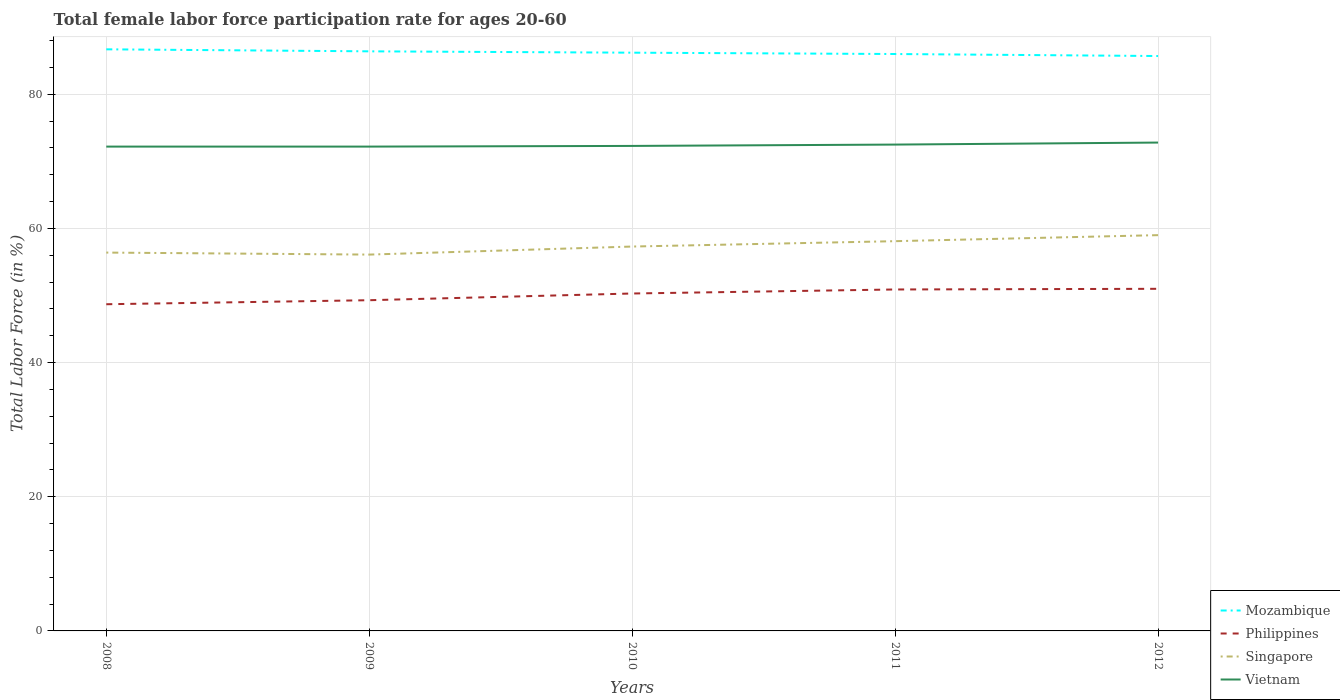How many different coloured lines are there?
Ensure brevity in your answer.  4. Across all years, what is the maximum female labor force participation rate in Philippines?
Ensure brevity in your answer.  48.7. What is the total female labor force participation rate in Vietnam in the graph?
Offer a terse response. -0.1. What is the difference between the highest and the second highest female labor force participation rate in Vietnam?
Make the answer very short. 0.6. What is the difference between the highest and the lowest female labor force participation rate in Philippines?
Your answer should be very brief. 3. Is the female labor force participation rate in Philippines strictly greater than the female labor force participation rate in Singapore over the years?
Make the answer very short. Yes. How many lines are there?
Your response must be concise. 4. Are the values on the major ticks of Y-axis written in scientific E-notation?
Make the answer very short. No. Does the graph contain any zero values?
Offer a very short reply. No. Does the graph contain grids?
Your response must be concise. Yes. How are the legend labels stacked?
Keep it short and to the point. Vertical. What is the title of the graph?
Keep it short and to the point. Total female labor force participation rate for ages 20-60. Does "New Caledonia" appear as one of the legend labels in the graph?
Offer a very short reply. No. What is the label or title of the Y-axis?
Give a very brief answer. Total Labor Force (in %). What is the Total Labor Force (in %) of Mozambique in 2008?
Ensure brevity in your answer.  86.7. What is the Total Labor Force (in %) in Philippines in 2008?
Offer a terse response. 48.7. What is the Total Labor Force (in %) of Singapore in 2008?
Provide a short and direct response. 56.4. What is the Total Labor Force (in %) in Vietnam in 2008?
Offer a very short reply. 72.2. What is the Total Labor Force (in %) in Mozambique in 2009?
Your response must be concise. 86.4. What is the Total Labor Force (in %) in Philippines in 2009?
Provide a short and direct response. 49.3. What is the Total Labor Force (in %) in Singapore in 2009?
Provide a succinct answer. 56.1. What is the Total Labor Force (in %) of Vietnam in 2009?
Make the answer very short. 72.2. What is the Total Labor Force (in %) of Mozambique in 2010?
Provide a succinct answer. 86.2. What is the Total Labor Force (in %) of Philippines in 2010?
Ensure brevity in your answer.  50.3. What is the Total Labor Force (in %) of Singapore in 2010?
Your answer should be compact. 57.3. What is the Total Labor Force (in %) of Vietnam in 2010?
Provide a succinct answer. 72.3. What is the Total Labor Force (in %) of Philippines in 2011?
Offer a very short reply. 50.9. What is the Total Labor Force (in %) in Singapore in 2011?
Ensure brevity in your answer.  58.1. What is the Total Labor Force (in %) in Vietnam in 2011?
Ensure brevity in your answer.  72.5. What is the Total Labor Force (in %) in Mozambique in 2012?
Ensure brevity in your answer.  85.7. What is the Total Labor Force (in %) of Vietnam in 2012?
Your answer should be very brief. 72.8. Across all years, what is the maximum Total Labor Force (in %) in Mozambique?
Keep it short and to the point. 86.7. Across all years, what is the maximum Total Labor Force (in %) in Philippines?
Your answer should be compact. 51. Across all years, what is the maximum Total Labor Force (in %) in Singapore?
Offer a very short reply. 59. Across all years, what is the maximum Total Labor Force (in %) in Vietnam?
Offer a terse response. 72.8. Across all years, what is the minimum Total Labor Force (in %) in Mozambique?
Ensure brevity in your answer.  85.7. Across all years, what is the minimum Total Labor Force (in %) of Philippines?
Provide a succinct answer. 48.7. Across all years, what is the minimum Total Labor Force (in %) of Singapore?
Offer a terse response. 56.1. Across all years, what is the minimum Total Labor Force (in %) of Vietnam?
Offer a very short reply. 72.2. What is the total Total Labor Force (in %) in Mozambique in the graph?
Your answer should be very brief. 431. What is the total Total Labor Force (in %) of Philippines in the graph?
Make the answer very short. 250.2. What is the total Total Labor Force (in %) in Singapore in the graph?
Ensure brevity in your answer.  286.9. What is the total Total Labor Force (in %) of Vietnam in the graph?
Provide a succinct answer. 362. What is the difference between the Total Labor Force (in %) in Singapore in 2008 and that in 2009?
Provide a succinct answer. 0.3. What is the difference between the Total Labor Force (in %) of Philippines in 2008 and that in 2010?
Ensure brevity in your answer.  -1.6. What is the difference between the Total Labor Force (in %) of Singapore in 2008 and that in 2010?
Give a very brief answer. -0.9. What is the difference between the Total Labor Force (in %) in Vietnam in 2008 and that in 2011?
Your answer should be very brief. -0.3. What is the difference between the Total Labor Force (in %) in Philippines in 2008 and that in 2012?
Offer a very short reply. -2.3. What is the difference between the Total Labor Force (in %) of Singapore in 2008 and that in 2012?
Provide a short and direct response. -2.6. What is the difference between the Total Labor Force (in %) in Singapore in 2009 and that in 2010?
Give a very brief answer. -1.2. What is the difference between the Total Labor Force (in %) in Singapore in 2009 and that in 2011?
Ensure brevity in your answer.  -2. What is the difference between the Total Labor Force (in %) of Mozambique in 2009 and that in 2012?
Your answer should be very brief. 0.7. What is the difference between the Total Labor Force (in %) in Singapore in 2009 and that in 2012?
Provide a short and direct response. -2.9. What is the difference between the Total Labor Force (in %) of Vietnam in 2009 and that in 2012?
Your answer should be very brief. -0.6. What is the difference between the Total Labor Force (in %) in Philippines in 2010 and that in 2011?
Offer a very short reply. -0.6. What is the difference between the Total Labor Force (in %) of Mozambique in 2010 and that in 2012?
Your response must be concise. 0.5. What is the difference between the Total Labor Force (in %) in Vietnam in 2010 and that in 2012?
Make the answer very short. -0.5. What is the difference between the Total Labor Force (in %) of Mozambique in 2011 and that in 2012?
Ensure brevity in your answer.  0.3. What is the difference between the Total Labor Force (in %) of Vietnam in 2011 and that in 2012?
Offer a terse response. -0.3. What is the difference between the Total Labor Force (in %) in Mozambique in 2008 and the Total Labor Force (in %) in Philippines in 2009?
Give a very brief answer. 37.4. What is the difference between the Total Labor Force (in %) of Mozambique in 2008 and the Total Labor Force (in %) of Singapore in 2009?
Keep it short and to the point. 30.6. What is the difference between the Total Labor Force (in %) in Philippines in 2008 and the Total Labor Force (in %) in Vietnam in 2009?
Offer a very short reply. -23.5. What is the difference between the Total Labor Force (in %) in Singapore in 2008 and the Total Labor Force (in %) in Vietnam in 2009?
Offer a terse response. -15.8. What is the difference between the Total Labor Force (in %) in Mozambique in 2008 and the Total Labor Force (in %) in Philippines in 2010?
Provide a succinct answer. 36.4. What is the difference between the Total Labor Force (in %) of Mozambique in 2008 and the Total Labor Force (in %) of Singapore in 2010?
Your answer should be very brief. 29.4. What is the difference between the Total Labor Force (in %) in Mozambique in 2008 and the Total Labor Force (in %) in Vietnam in 2010?
Offer a very short reply. 14.4. What is the difference between the Total Labor Force (in %) of Philippines in 2008 and the Total Labor Force (in %) of Vietnam in 2010?
Your answer should be compact. -23.6. What is the difference between the Total Labor Force (in %) in Singapore in 2008 and the Total Labor Force (in %) in Vietnam in 2010?
Offer a terse response. -15.9. What is the difference between the Total Labor Force (in %) of Mozambique in 2008 and the Total Labor Force (in %) of Philippines in 2011?
Provide a succinct answer. 35.8. What is the difference between the Total Labor Force (in %) in Mozambique in 2008 and the Total Labor Force (in %) in Singapore in 2011?
Your answer should be very brief. 28.6. What is the difference between the Total Labor Force (in %) in Philippines in 2008 and the Total Labor Force (in %) in Singapore in 2011?
Your answer should be very brief. -9.4. What is the difference between the Total Labor Force (in %) in Philippines in 2008 and the Total Labor Force (in %) in Vietnam in 2011?
Your answer should be very brief. -23.8. What is the difference between the Total Labor Force (in %) of Singapore in 2008 and the Total Labor Force (in %) of Vietnam in 2011?
Offer a terse response. -16.1. What is the difference between the Total Labor Force (in %) in Mozambique in 2008 and the Total Labor Force (in %) in Philippines in 2012?
Your answer should be compact. 35.7. What is the difference between the Total Labor Force (in %) of Mozambique in 2008 and the Total Labor Force (in %) of Singapore in 2012?
Give a very brief answer. 27.7. What is the difference between the Total Labor Force (in %) of Mozambique in 2008 and the Total Labor Force (in %) of Vietnam in 2012?
Your response must be concise. 13.9. What is the difference between the Total Labor Force (in %) in Philippines in 2008 and the Total Labor Force (in %) in Vietnam in 2012?
Provide a succinct answer. -24.1. What is the difference between the Total Labor Force (in %) in Singapore in 2008 and the Total Labor Force (in %) in Vietnam in 2012?
Provide a succinct answer. -16.4. What is the difference between the Total Labor Force (in %) in Mozambique in 2009 and the Total Labor Force (in %) in Philippines in 2010?
Provide a succinct answer. 36.1. What is the difference between the Total Labor Force (in %) of Mozambique in 2009 and the Total Labor Force (in %) of Singapore in 2010?
Provide a short and direct response. 29.1. What is the difference between the Total Labor Force (in %) of Philippines in 2009 and the Total Labor Force (in %) of Vietnam in 2010?
Your response must be concise. -23. What is the difference between the Total Labor Force (in %) of Singapore in 2009 and the Total Labor Force (in %) of Vietnam in 2010?
Give a very brief answer. -16.2. What is the difference between the Total Labor Force (in %) of Mozambique in 2009 and the Total Labor Force (in %) of Philippines in 2011?
Your answer should be compact. 35.5. What is the difference between the Total Labor Force (in %) of Mozambique in 2009 and the Total Labor Force (in %) of Singapore in 2011?
Keep it short and to the point. 28.3. What is the difference between the Total Labor Force (in %) in Philippines in 2009 and the Total Labor Force (in %) in Singapore in 2011?
Keep it short and to the point. -8.8. What is the difference between the Total Labor Force (in %) of Philippines in 2009 and the Total Labor Force (in %) of Vietnam in 2011?
Your response must be concise. -23.2. What is the difference between the Total Labor Force (in %) in Singapore in 2009 and the Total Labor Force (in %) in Vietnam in 2011?
Make the answer very short. -16.4. What is the difference between the Total Labor Force (in %) in Mozambique in 2009 and the Total Labor Force (in %) in Philippines in 2012?
Ensure brevity in your answer.  35.4. What is the difference between the Total Labor Force (in %) of Mozambique in 2009 and the Total Labor Force (in %) of Singapore in 2012?
Your response must be concise. 27.4. What is the difference between the Total Labor Force (in %) in Mozambique in 2009 and the Total Labor Force (in %) in Vietnam in 2012?
Ensure brevity in your answer.  13.6. What is the difference between the Total Labor Force (in %) of Philippines in 2009 and the Total Labor Force (in %) of Singapore in 2012?
Ensure brevity in your answer.  -9.7. What is the difference between the Total Labor Force (in %) of Philippines in 2009 and the Total Labor Force (in %) of Vietnam in 2012?
Offer a very short reply. -23.5. What is the difference between the Total Labor Force (in %) of Singapore in 2009 and the Total Labor Force (in %) of Vietnam in 2012?
Make the answer very short. -16.7. What is the difference between the Total Labor Force (in %) of Mozambique in 2010 and the Total Labor Force (in %) of Philippines in 2011?
Keep it short and to the point. 35.3. What is the difference between the Total Labor Force (in %) in Mozambique in 2010 and the Total Labor Force (in %) in Singapore in 2011?
Your answer should be compact. 28.1. What is the difference between the Total Labor Force (in %) of Philippines in 2010 and the Total Labor Force (in %) of Singapore in 2011?
Your response must be concise. -7.8. What is the difference between the Total Labor Force (in %) of Philippines in 2010 and the Total Labor Force (in %) of Vietnam in 2011?
Provide a short and direct response. -22.2. What is the difference between the Total Labor Force (in %) of Singapore in 2010 and the Total Labor Force (in %) of Vietnam in 2011?
Keep it short and to the point. -15.2. What is the difference between the Total Labor Force (in %) of Mozambique in 2010 and the Total Labor Force (in %) of Philippines in 2012?
Your answer should be very brief. 35.2. What is the difference between the Total Labor Force (in %) of Mozambique in 2010 and the Total Labor Force (in %) of Singapore in 2012?
Give a very brief answer. 27.2. What is the difference between the Total Labor Force (in %) of Philippines in 2010 and the Total Labor Force (in %) of Singapore in 2012?
Your answer should be compact. -8.7. What is the difference between the Total Labor Force (in %) in Philippines in 2010 and the Total Labor Force (in %) in Vietnam in 2012?
Offer a very short reply. -22.5. What is the difference between the Total Labor Force (in %) in Singapore in 2010 and the Total Labor Force (in %) in Vietnam in 2012?
Offer a very short reply. -15.5. What is the difference between the Total Labor Force (in %) in Mozambique in 2011 and the Total Labor Force (in %) in Philippines in 2012?
Give a very brief answer. 35. What is the difference between the Total Labor Force (in %) of Mozambique in 2011 and the Total Labor Force (in %) of Singapore in 2012?
Your answer should be compact. 27. What is the difference between the Total Labor Force (in %) in Mozambique in 2011 and the Total Labor Force (in %) in Vietnam in 2012?
Provide a succinct answer. 13.2. What is the difference between the Total Labor Force (in %) in Philippines in 2011 and the Total Labor Force (in %) in Vietnam in 2012?
Ensure brevity in your answer.  -21.9. What is the difference between the Total Labor Force (in %) of Singapore in 2011 and the Total Labor Force (in %) of Vietnam in 2012?
Ensure brevity in your answer.  -14.7. What is the average Total Labor Force (in %) in Mozambique per year?
Offer a terse response. 86.2. What is the average Total Labor Force (in %) in Philippines per year?
Make the answer very short. 50.04. What is the average Total Labor Force (in %) of Singapore per year?
Your answer should be compact. 57.38. What is the average Total Labor Force (in %) in Vietnam per year?
Keep it short and to the point. 72.4. In the year 2008, what is the difference between the Total Labor Force (in %) of Mozambique and Total Labor Force (in %) of Philippines?
Offer a terse response. 38. In the year 2008, what is the difference between the Total Labor Force (in %) in Mozambique and Total Labor Force (in %) in Singapore?
Offer a very short reply. 30.3. In the year 2008, what is the difference between the Total Labor Force (in %) of Philippines and Total Labor Force (in %) of Vietnam?
Your response must be concise. -23.5. In the year 2008, what is the difference between the Total Labor Force (in %) of Singapore and Total Labor Force (in %) of Vietnam?
Make the answer very short. -15.8. In the year 2009, what is the difference between the Total Labor Force (in %) in Mozambique and Total Labor Force (in %) in Philippines?
Make the answer very short. 37.1. In the year 2009, what is the difference between the Total Labor Force (in %) in Mozambique and Total Labor Force (in %) in Singapore?
Your answer should be compact. 30.3. In the year 2009, what is the difference between the Total Labor Force (in %) in Philippines and Total Labor Force (in %) in Singapore?
Your response must be concise. -6.8. In the year 2009, what is the difference between the Total Labor Force (in %) of Philippines and Total Labor Force (in %) of Vietnam?
Your response must be concise. -22.9. In the year 2009, what is the difference between the Total Labor Force (in %) in Singapore and Total Labor Force (in %) in Vietnam?
Provide a short and direct response. -16.1. In the year 2010, what is the difference between the Total Labor Force (in %) of Mozambique and Total Labor Force (in %) of Philippines?
Provide a succinct answer. 35.9. In the year 2010, what is the difference between the Total Labor Force (in %) in Mozambique and Total Labor Force (in %) in Singapore?
Give a very brief answer. 28.9. In the year 2010, what is the difference between the Total Labor Force (in %) in Philippines and Total Labor Force (in %) in Singapore?
Your response must be concise. -7. In the year 2010, what is the difference between the Total Labor Force (in %) in Philippines and Total Labor Force (in %) in Vietnam?
Keep it short and to the point. -22. In the year 2011, what is the difference between the Total Labor Force (in %) in Mozambique and Total Labor Force (in %) in Philippines?
Give a very brief answer. 35.1. In the year 2011, what is the difference between the Total Labor Force (in %) in Mozambique and Total Labor Force (in %) in Singapore?
Your answer should be very brief. 27.9. In the year 2011, what is the difference between the Total Labor Force (in %) of Philippines and Total Labor Force (in %) of Vietnam?
Your answer should be very brief. -21.6. In the year 2011, what is the difference between the Total Labor Force (in %) of Singapore and Total Labor Force (in %) of Vietnam?
Ensure brevity in your answer.  -14.4. In the year 2012, what is the difference between the Total Labor Force (in %) of Mozambique and Total Labor Force (in %) of Philippines?
Keep it short and to the point. 34.7. In the year 2012, what is the difference between the Total Labor Force (in %) in Mozambique and Total Labor Force (in %) in Singapore?
Offer a very short reply. 26.7. In the year 2012, what is the difference between the Total Labor Force (in %) in Philippines and Total Labor Force (in %) in Singapore?
Your answer should be very brief. -8. In the year 2012, what is the difference between the Total Labor Force (in %) of Philippines and Total Labor Force (in %) of Vietnam?
Provide a short and direct response. -21.8. What is the ratio of the Total Labor Force (in %) of Mozambique in 2008 to that in 2009?
Ensure brevity in your answer.  1. What is the ratio of the Total Labor Force (in %) in Singapore in 2008 to that in 2009?
Your answer should be very brief. 1.01. What is the ratio of the Total Labor Force (in %) in Vietnam in 2008 to that in 2009?
Your response must be concise. 1. What is the ratio of the Total Labor Force (in %) of Mozambique in 2008 to that in 2010?
Make the answer very short. 1.01. What is the ratio of the Total Labor Force (in %) in Philippines in 2008 to that in 2010?
Provide a short and direct response. 0.97. What is the ratio of the Total Labor Force (in %) of Singapore in 2008 to that in 2010?
Provide a short and direct response. 0.98. What is the ratio of the Total Labor Force (in %) in Vietnam in 2008 to that in 2010?
Offer a terse response. 1. What is the ratio of the Total Labor Force (in %) of Mozambique in 2008 to that in 2011?
Offer a very short reply. 1.01. What is the ratio of the Total Labor Force (in %) of Philippines in 2008 to that in 2011?
Offer a very short reply. 0.96. What is the ratio of the Total Labor Force (in %) of Singapore in 2008 to that in 2011?
Provide a succinct answer. 0.97. What is the ratio of the Total Labor Force (in %) of Mozambique in 2008 to that in 2012?
Your response must be concise. 1.01. What is the ratio of the Total Labor Force (in %) of Philippines in 2008 to that in 2012?
Give a very brief answer. 0.95. What is the ratio of the Total Labor Force (in %) in Singapore in 2008 to that in 2012?
Provide a short and direct response. 0.96. What is the ratio of the Total Labor Force (in %) of Mozambique in 2009 to that in 2010?
Offer a terse response. 1. What is the ratio of the Total Labor Force (in %) of Philippines in 2009 to that in 2010?
Give a very brief answer. 0.98. What is the ratio of the Total Labor Force (in %) in Singapore in 2009 to that in 2010?
Provide a succinct answer. 0.98. What is the ratio of the Total Labor Force (in %) in Vietnam in 2009 to that in 2010?
Provide a succinct answer. 1. What is the ratio of the Total Labor Force (in %) of Philippines in 2009 to that in 2011?
Your response must be concise. 0.97. What is the ratio of the Total Labor Force (in %) in Singapore in 2009 to that in 2011?
Provide a short and direct response. 0.97. What is the ratio of the Total Labor Force (in %) in Mozambique in 2009 to that in 2012?
Give a very brief answer. 1.01. What is the ratio of the Total Labor Force (in %) in Philippines in 2009 to that in 2012?
Offer a terse response. 0.97. What is the ratio of the Total Labor Force (in %) of Singapore in 2009 to that in 2012?
Your response must be concise. 0.95. What is the ratio of the Total Labor Force (in %) of Vietnam in 2009 to that in 2012?
Ensure brevity in your answer.  0.99. What is the ratio of the Total Labor Force (in %) in Philippines in 2010 to that in 2011?
Your answer should be compact. 0.99. What is the ratio of the Total Labor Force (in %) of Singapore in 2010 to that in 2011?
Your answer should be compact. 0.99. What is the ratio of the Total Labor Force (in %) of Vietnam in 2010 to that in 2011?
Give a very brief answer. 1. What is the ratio of the Total Labor Force (in %) of Philippines in 2010 to that in 2012?
Your response must be concise. 0.99. What is the ratio of the Total Labor Force (in %) in Singapore in 2010 to that in 2012?
Keep it short and to the point. 0.97. What is the ratio of the Total Labor Force (in %) of Vietnam in 2010 to that in 2012?
Keep it short and to the point. 0.99. What is the ratio of the Total Labor Force (in %) in Philippines in 2011 to that in 2012?
Ensure brevity in your answer.  1. What is the ratio of the Total Labor Force (in %) of Singapore in 2011 to that in 2012?
Your response must be concise. 0.98. What is the ratio of the Total Labor Force (in %) of Vietnam in 2011 to that in 2012?
Keep it short and to the point. 1. What is the difference between the highest and the second highest Total Labor Force (in %) of Mozambique?
Your response must be concise. 0.3. What is the difference between the highest and the second highest Total Labor Force (in %) of Philippines?
Provide a succinct answer. 0.1. What is the difference between the highest and the second highest Total Labor Force (in %) in Vietnam?
Ensure brevity in your answer.  0.3. What is the difference between the highest and the lowest Total Labor Force (in %) of Philippines?
Make the answer very short. 2.3. What is the difference between the highest and the lowest Total Labor Force (in %) of Singapore?
Ensure brevity in your answer.  2.9. What is the difference between the highest and the lowest Total Labor Force (in %) in Vietnam?
Provide a succinct answer. 0.6. 